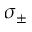<formula> <loc_0><loc_0><loc_500><loc_500>\sigma _ { \pm }</formula> 